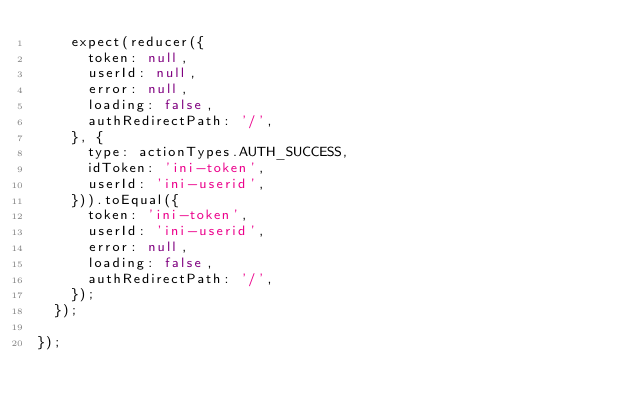Convert code to text. <code><loc_0><loc_0><loc_500><loc_500><_JavaScript_>    expect(reducer({
      token: null,
      userId: null,
      error: null,
      loading: false,
      authRedirectPath: '/',
    }, {
      type: actionTypes.AUTH_SUCCESS,
      idToken: 'ini-token',
      userId: 'ini-userid',
    })).toEqual({
      token: 'ini-token',
      userId: 'ini-userid',
      error: null,
      loading: false,
      authRedirectPath: '/',
    });
  });

});</code> 